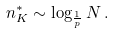Convert formula to latex. <formula><loc_0><loc_0><loc_500><loc_500>n ^ { * } _ { K } \sim \log _ { \frac { 1 } { p } } N \, .</formula> 